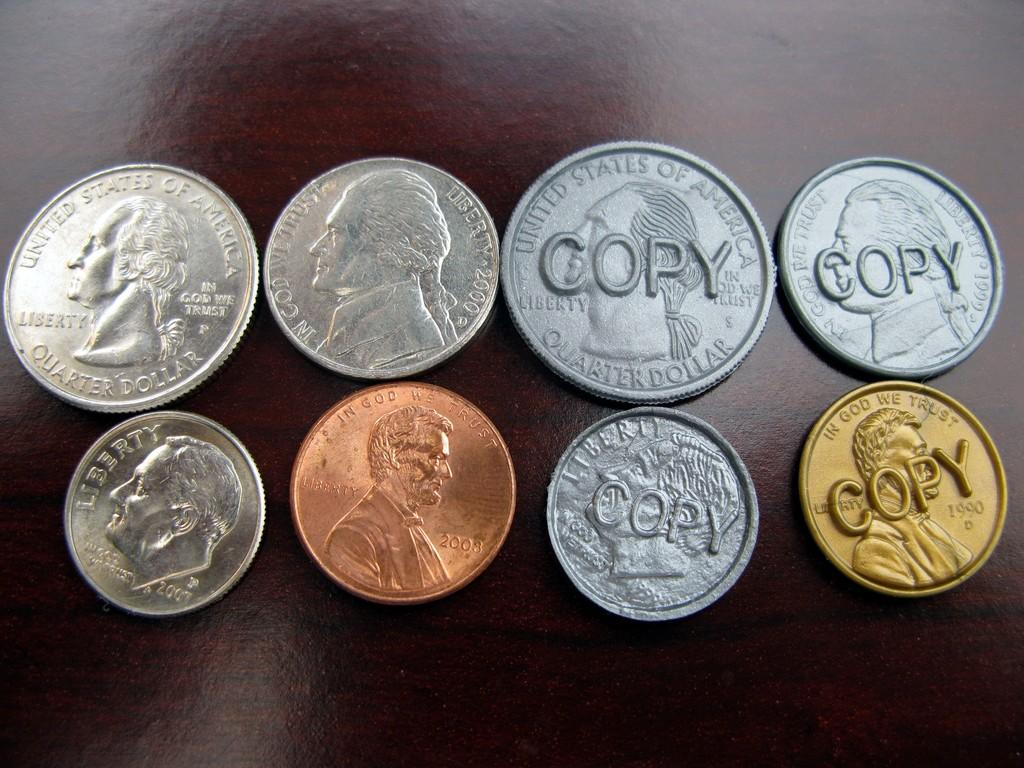What type of objects are present in the image? There are metal coins in the image. What is the surface on which the coins are placed? The coins are placed on a wooden surface. Are there any designs or images on the wooden surface? Yes, images are visible on the wooden surface. What colors of coins can be seen in the image? There is a copper coin and a gold coin in the image. Where is the rabbit sitting on the wooden surface in the image? There is no rabbit present in the image; it only features metal coins on a wooden surface with images. 